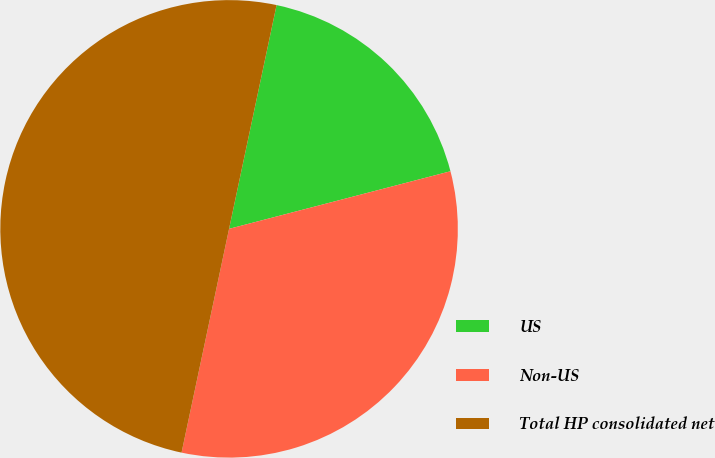Convert chart to OTSL. <chart><loc_0><loc_0><loc_500><loc_500><pie_chart><fcel>US<fcel>Non-US<fcel>Total HP consolidated net<nl><fcel>17.62%<fcel>32.38%<fcel>50.0%<nl></chart> 